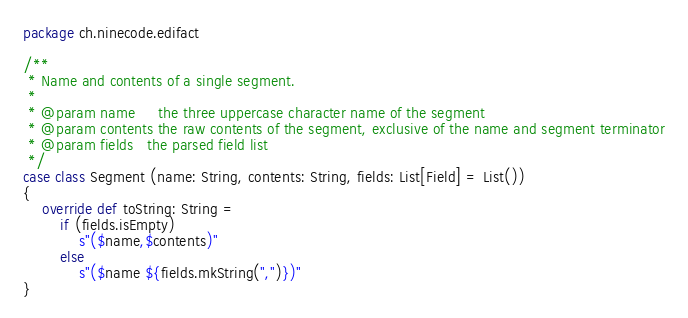Convert code to text. <code><loc_0><loc_0><loc_500><loc_500><_Scala_>package ch.ninecode.edifact

/**
 * Name and contents of a single segment.
 *
 * @param name     the three uppercase character name of the segment
 * @param contents the raw contents of the segment, exclusive of the name and segment terminator
 * @param fields   the parsed field list
 */
case class Segment (name: String, contents: String, fields: List[Field] = List())
{
    override def toString: String =
        if (fields.isEmpty)
            s"($name,$contents)"
        else
            s"($name ${fields.mkString(",")})"
}
</code> 